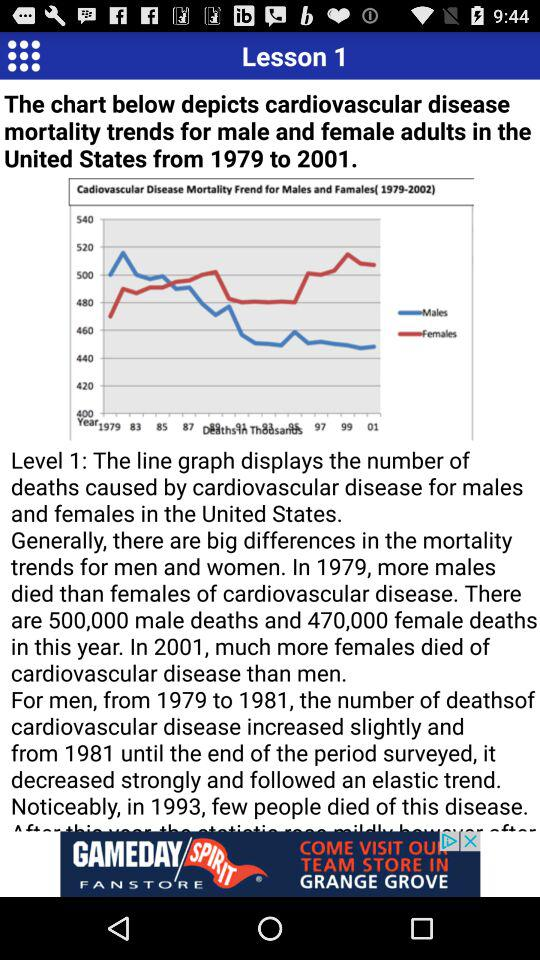From which year is the US disease graph showing up? The year is from 1979 to 2001. 